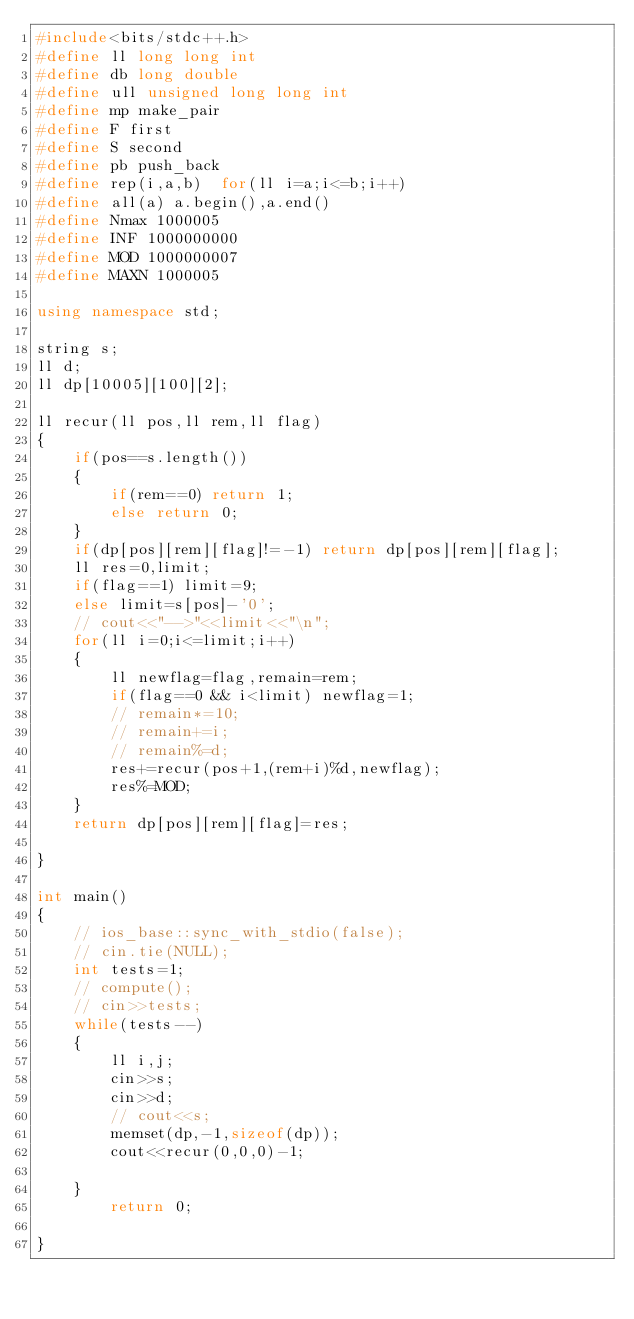Convert code to text. <code><loc_0><loc_0><loc_500><loc_500><_C++_>#include<bits/stdc++.h>
#define ll long long int
#define db long double
#define ull unsigned long long int
#define mp make_pair
#define F first
#define S second
#define pb push_back
#define rep(i,a,b)  for(ll i=a;i<=b;i++)
#define all(a) a.begin(),a.end()
#define Nmax 1000005
#define INF 1000000000
#define MOD 1000000007
#define MAXN 1000005
 
using namespace std;

string s;
ll d;
ll dp[10005][100][2];

ll recur(ll pos,ll rem,ll flag)
{
	if(pos==s.length())
	{
		if(rem==0) return 1;
		else return 0;
	}
	if(dp[pos][rem][flag]!=-1) return dp[pos][rem][flag];
	ll res=0,limit;
	if(flag==1) limit=9;
	else limit=s[pos]-'0';
	// cout<<"-->"<<limit<<"\n";
	for(ll i=0;i<=limit;i++)
	{
		ll newflag=flag,remain=rem;
		if(flag==0 && i<limit) newflag=1;
		// remain*=10;
		// remain+=i;
		// remain%=d;
		res+=recur(pos+1,(rem+i)%d,newflag);
		res%=MOD;
	}
	return dp[pos][rem][flag]=res;

}

int main()
{
    // ios_base::sync_with_stdio(false);
    // cin.tie(NULL);
    int tests=1;
    // compute();
    // cin>>tests;
    while(tests--)
    {
    	ll i,j;
    	cin>>s;
    	cin>>d;
    	// cout<<s;
    	memset(dp,-1,sizeof(dp));
    	cout<<recur(0,0,0)-1;

    }
    	return 0;
    
}</code> 